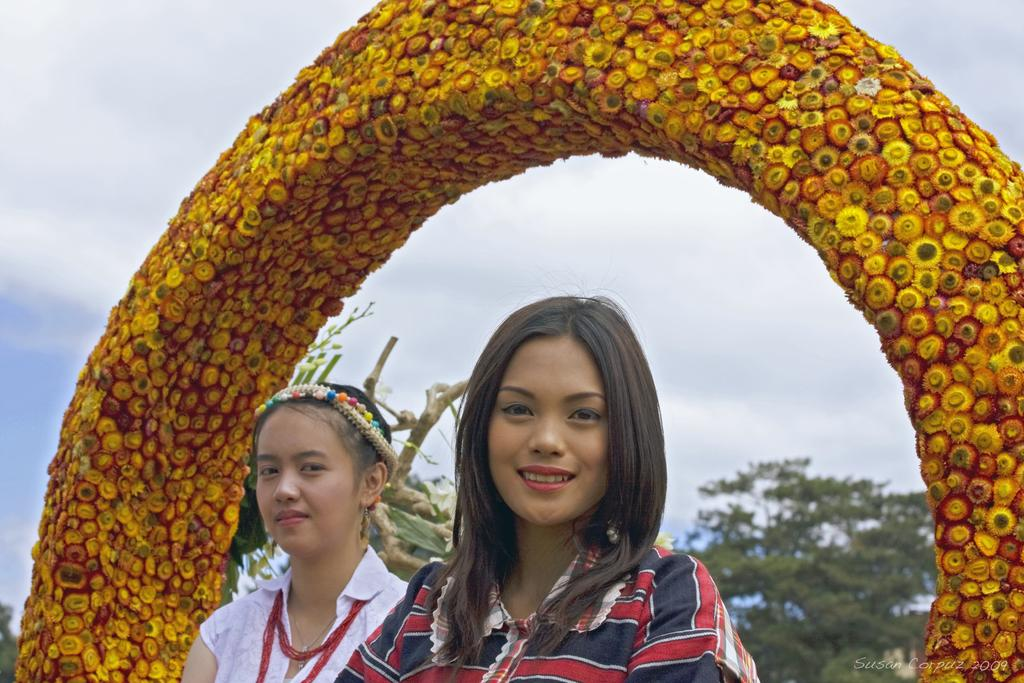How many people are in the image? There are two women standing in the middle of the image. What is located behind the women? There is an arch behind the women. What can be seen behind the arch? There are trees visible behind the arch. What is visible at the top of the image? The sky is visible at the top of the image. What can be observed in the sky? There are clouds in the sky. What type of hospital is visible in the image? There is no hospital present in the image. What do the women believe about the doctor in the image? There is no doctor or indication of belief in the image. 